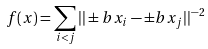Convert formula to latex. <formula><loc_0><loc_0><loc_500><loc_500>f ( x ) = \sum _ { i < j } | | \pm b { x } _ { i } - \pm b { x } _ { j } | | ^ { - 2 }</formula> 